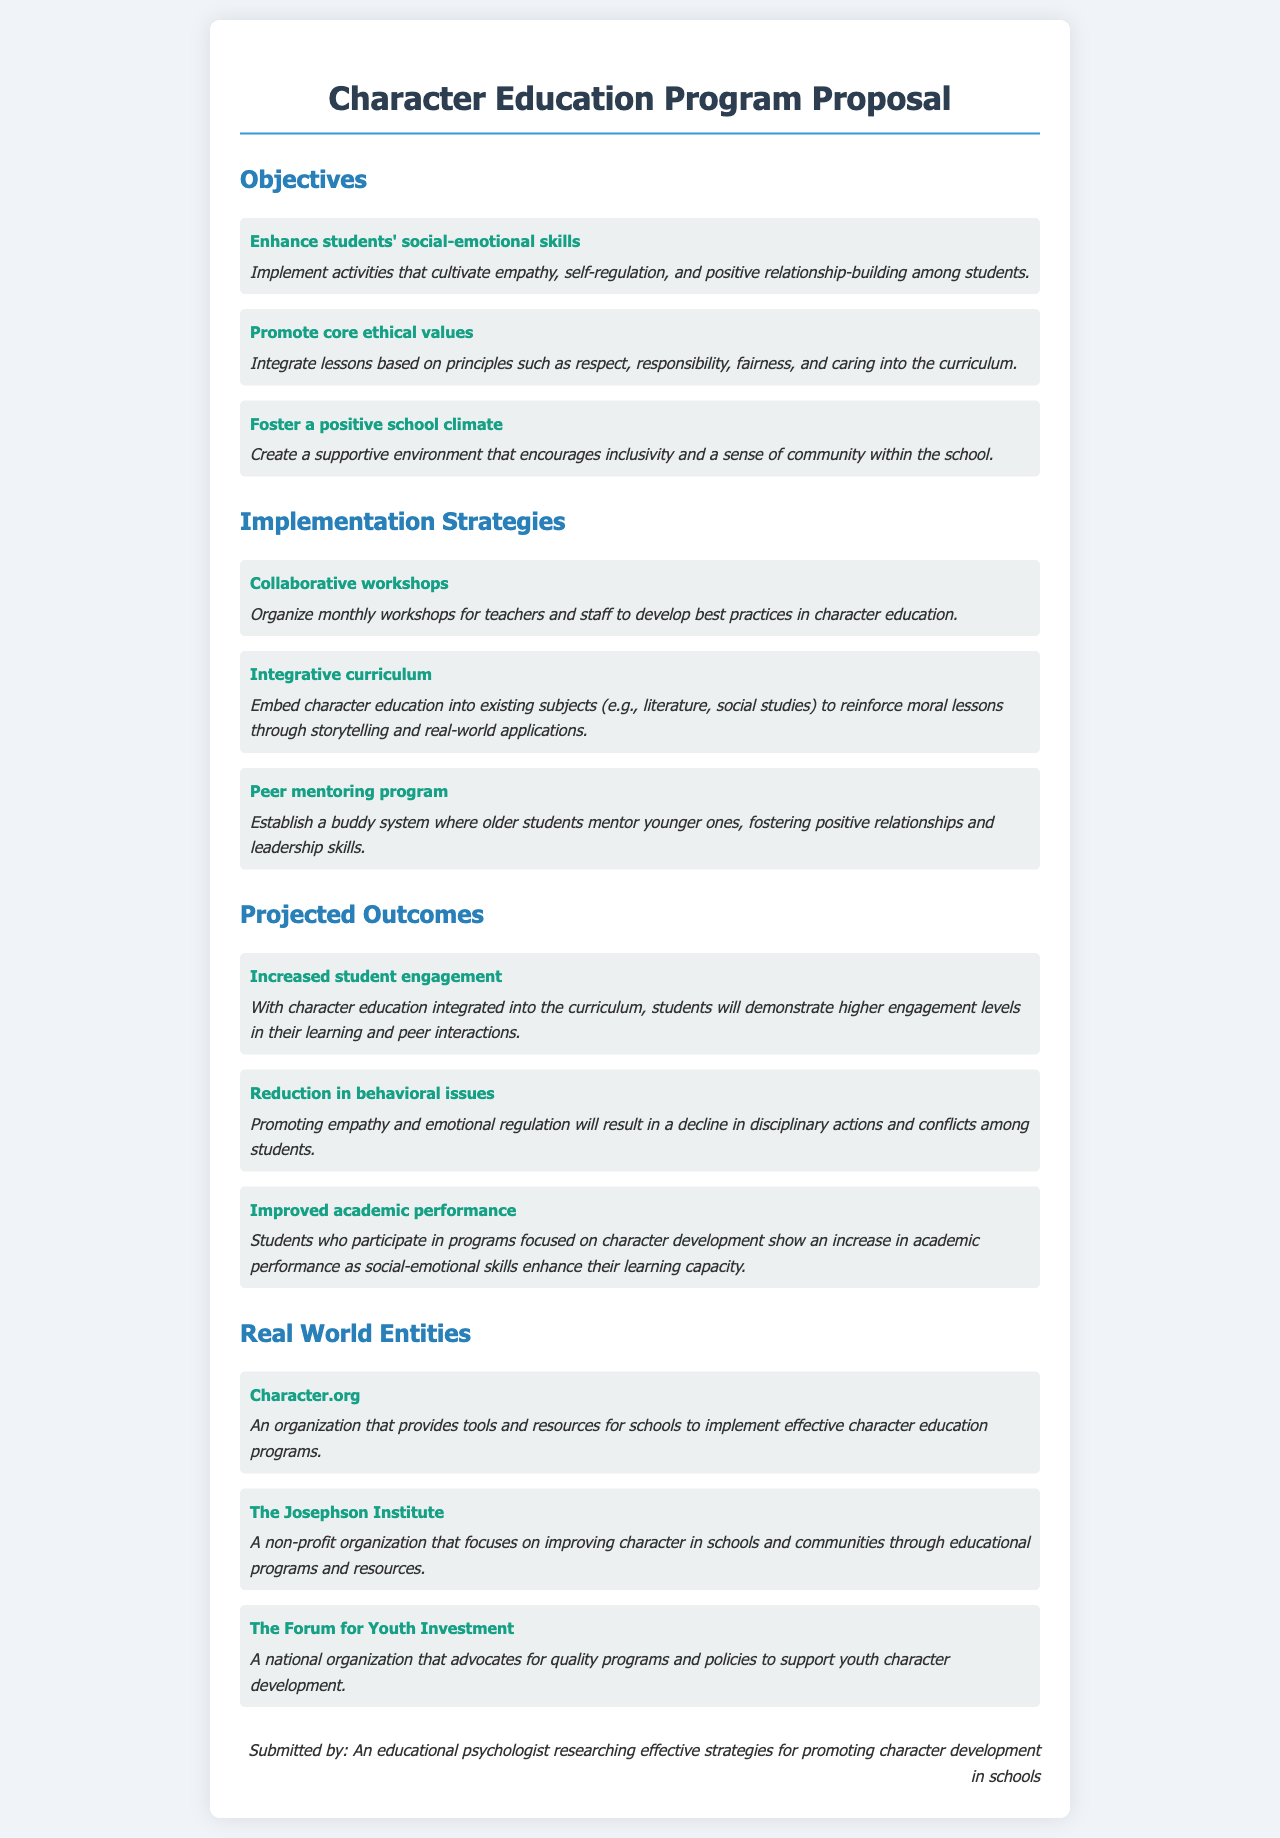what is the first objective listed? The first objective is about enhancing students' social-emotional skills as stated in the document.
Answer: Enhance students' social-emotional skills what is one implementation strategy proposed? The proposal includes various strategies, one of which is organized monthly workshops for teachers.
Answer: Collaborative workshops how many projected outcomes are listed? The document outlines three projected outcomes of the character education program.
Answer: Three which organization is mentioned as a resource for character education? The document provides a few entities, one of which is Character.org, known for supporting schools in character education.
Answer: Character.org what is the second projected outcome? The second projected outcome focuses on a reduction in behavioral issues among students.
Answer: Reduction in behavioral issues what is the purpose of the peer mentoring program? The peer mentoring program aims to establish relationships where older students mentor younger ones, promoting leadership and positive interactions.
Answer: Foster positive relationships and leadership skills what ethical values are promoted in the character education program? The program promotes core ethical values such as respect, responsibility, fairness, and caring.
Answer: Respect, responsibility, fairness, and caring who submitted the proposal? The proposal is submitted by an educational psychologist focusing on character development strategies in schools.
Answer: An educational psychologist researching effective strategies for promoting character development in schools 